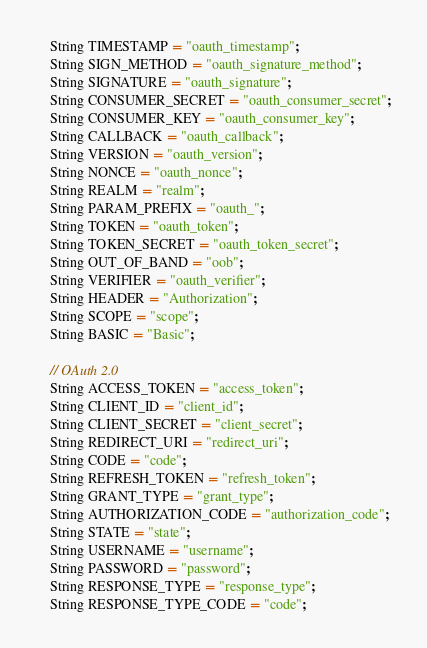Convert code to text. <code><loc_0><loc_0><loc_500><loc_500><_Java_>
    String TIMESTAMP = "oauth_timestamp";
    String SIGN_METHOD = "oauth_signature_method";
    String SIGNATURE = "oauth_signature";
    String CONSUMER_SECRET = "oauth_consumer_secret";
    String CONSUMER_KEY = "oauth_consumer_key";
    String CALLBACK = "oauth_callback";
    String VERSION = "oauth_version";
    String NONCE = "oauth_nonce";
    String REALM = "realm";
    String PARAM_PREFIX = "oauth_";
    String TOKEN = "oauth_token";
    String TOKEN_SECRET = "oauth_token_secret";
    String OUT_OF_BAND = "oob";
    String VERIFIER = "oauth_verifier";
    String HEADER = "Authorization";
    String SCOPE = "scope";
    String BASIC = "Basic";

    // OAuth 2.0
    String ACCESS_TOKEN = "access_token";
    String CLIENT_ID = "client_id";
    String CLIENT_SECRET = "client_secret";
    String REDIRECT_URI = "redirect_uri";
    String CODE = "code";
    String REFRESH_TOKEN = "refresh_token";
    String GRANT_TYPE = "grant_type";
    String AUTHORIZATION_CODE = "authorization_code";
    String STATE = "state";
    String USERNAME = "username";
    String PASSWORD = "password";
    String RESPONSE_TYPE = "response_type";
    String RESPONSE_TYPE_CODE = "code";</code> 